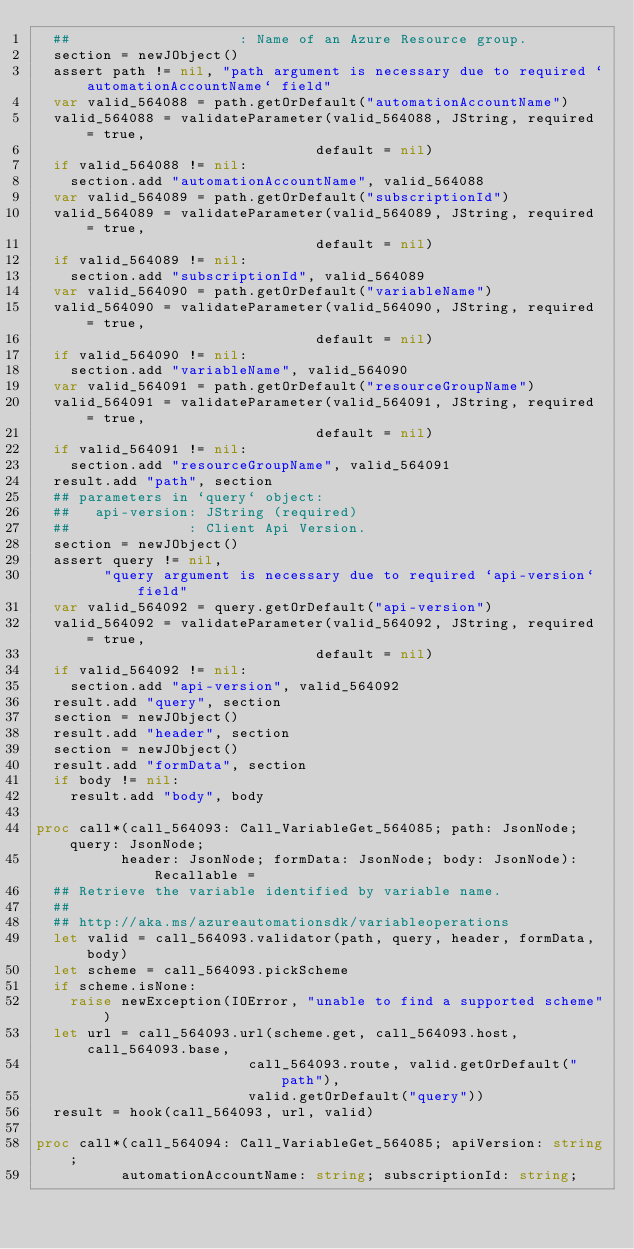<code> <loc_0><loc_0><loc_500><loc_500><_Nim_>  ##                    : Name of an Azure Resource group.
  section = newJObject()
  assert path != nil, "path argument is necessary due to required `automationAccountName` field"
  var valid_564088 = path.getOrDefault("automationAccountName")
  valid_564088 = validateParameter(valid_564088, JString, required = true,
                                 default = nil)
  if valid_564088 != nil:
    section.add "automationAccountName", valid_564088
  var valid_564089 = path.getOrDefault("subscriptionId")
  valid_564089 = validateParameter(valid_564089, JString, required = true,
                                 default = nil)
  if valid_564089 != nil:
    section.add "subscriptionId", valid_564089
  var valid_564090 = path.getOrDefault("variableName")
  valid_564090 = validateParameter(valid_564090, JString, required = true,
                                 default = nil)
  if valid_564090 != nil:
    section.add "variableName", valid_564090
  var valid_564091 = path.getOrDefault("resourceGroupName")
  valid_564091 = validateParameter(valid_564091, JString, required = true,
                                 default = nil)
  if valid_564091 != nil:
    section.add "resourceGroupName", valid_564091
  result.add "path", section
  ## parameters in `query` object:
  ##   api-version: JString (required)
  ##              : Client Api Version.
  section = newJObject()
  assert query != nil,
        "query argument is necessary due to required `api-version` field"
  var valid_564092 = query.getOrDefault("api-version")
  valid_564092 = validateParameter(valid_564092, JString, required = true,
                                 default = nil)
  if valid_564092 != nil:
    section.add "api-version", valid_564092
  result.add "query", section
  section = newJObject()
  result.add "header", section
  section = newJObject()
  result.add "formData", section
  if body != nil:
    result.add "body", body

proc call*(call_564093: Call_VariableGet_564085; path: JsonNode; query: JsonNode;
          header: JsonNode; formData: JsonNode; body: JsonNode): Recallable =
  ## Retrieve the variable identified by variable name.
  ## 
  ## http://aka.ms/azureautomationsdk/variableoperations
  let valid = call_564093.validator(path, query, header, formData, body)
  let scheme = call_564093.pickScheme
  if scheme.isNone:
    raise newException(IOError, "unable to find a supported scheme")
  let url = call_564093.url(scheme.get, call_564093.host, call_564093.base,
                         call_564093.route, valid.getOrDefault("path"),
                         valid.getOrDefault("query"))
  result = hook(call_564093, url, valid)

proc call*(call_564094: Call_VariableGet_564085; apiVersion: string;
          automationAccountName: string; subscriptionId: string;</code> 